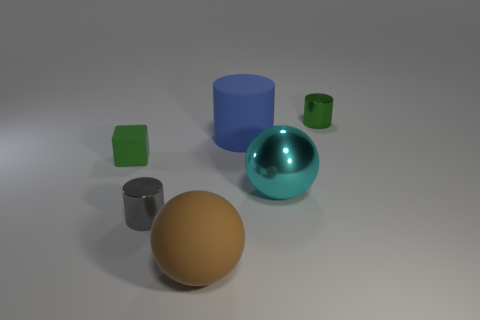What material is the cylinder in front of the big blue thing?
Keep it short and to the point. Metal. There is a blue rubber thing; is it the same shape as the tiny shiny thing behind the green cube?
Offer a terse response. Yes. Is the number of big cyan balls right of the brown rubber sphere the same as the number of cubes right of the small gray metal thing?
Offer a terse response. No. How many other objects are the same material as the cyan object?
Make the answer very short. 2. How many metallic things are gray objects or large blue cylinders?
Make the answer very short. 1. There is a tiny thing that is on the left side of the small gray object; is its shape the same as the large blue matte thing?
Offer a very short reply. No. Are there more large brown balls behind the brown rubber thing than red balls?
Provide a short and direct response. No. How many small objects are on the right side of the large brown sphere and to the left of the tiny gray cylinder?
Provide a succinct answer. 0. There is a shiny cylinder right of the cylinder in front of the cyan metallic sphere; what is its color?
Make the answer very short. Green. How many large things have the same color as the tiny rubber object?
Provide a succinct answer. 0. 